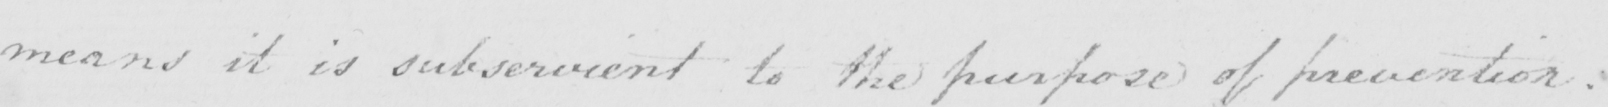What is written in this line of handwriting? means it is subservient to the purpose of prevention. 